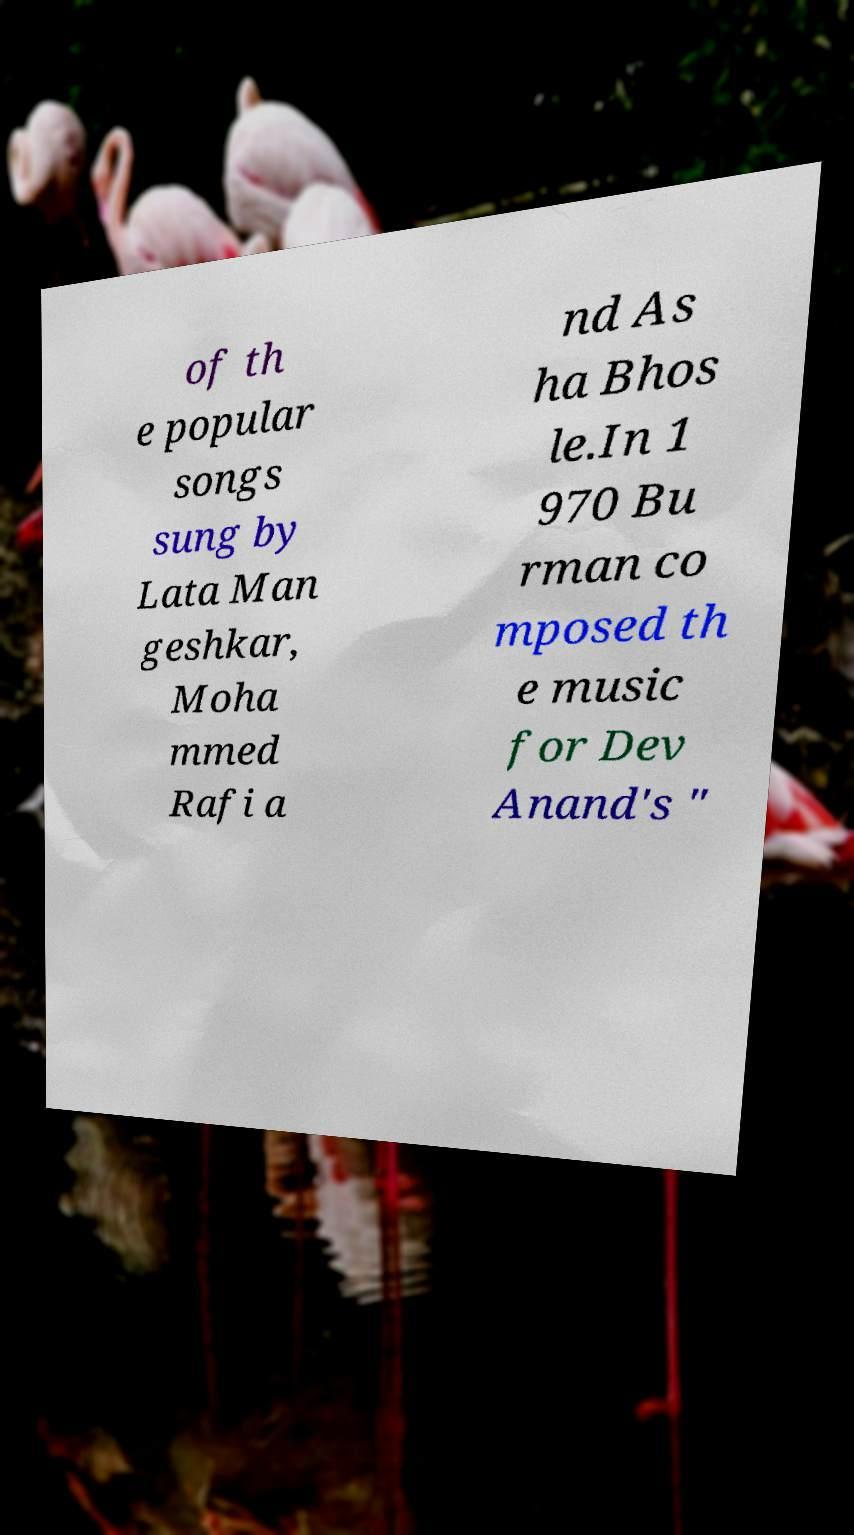Please identify and transcribe the text found in this image. of th e popular songs sung by Lata Man geshkar, Moha mmed Rafi a nd As ha Bhos le.In 1 970 Bu rman co mposed th e music for Dev Anand's " 